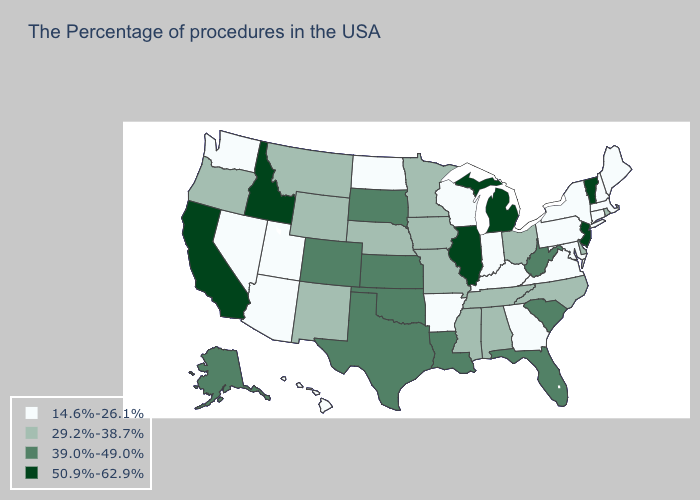Which states have the lowest value in the USA?
Keep it brief. Maine, Massachusetts, New Hampshire, Connecticut, New York, Maryland, Pennsylvania, Virginia, Georgia, Kentucky, Indiana, Wisconsin, Arkansas, North Dakota, Utah, Arizona, Nevada, Washington, Hawaii. Name the states that have a value in the range 50.9%-62.9%?
Quick response, please. Vermont, New Jersey, Michigan, Illinois, Idaho, California. Does the first symbol in the legend represent the smallest category?
Write a very short answer. Yes. Does the first symbol in the legend represent the smallest category?
Give a very brief answer. Yes. Does Idaho have the highest value in the USA?
Keep it brief. Yes. What is the value of Nebraska?
Concise answer only. 29.2%-38.7%. What is the lowest value in states that border Virginia?
Be succinct. 14.6%-26.1%. What is the highest value in states that border Nebraska?
Give a very brief answer. 39.0%-49.0%. Among the states that border New York , does Pennsylvania have the lowest value?
Be succinct. Yes. What is the highest value in states that border Louisiana?
Give a very brief answer. 39.0%-49.0%. What is the lowest value in the USA?
Keep it brief. 14.6%-26.1%. Name the states that have a value in the range 14.6%-26.1%?
Keep it brief. Maine, Massachusetts, New Hampshire, Connecticut, New York, Maryland, Pennsylvania, Virginia, Georgia, Kentucky, Indiana, Wisconsin, Arkansas, North Dakota, Utah, Arizona, Nevada, Washington, Hawaii. Name the states that have a value in the range 14.6%-26.1%?
Write a very short answer. Maine, Massachusetts, New Hampshire, Connecticut, New York, Maryland, Pennsylvania, Virginia, Georgia, Kentucky, Indiana, Wisconsin, Arkansas, North Dakota, Utah, Arizona, Nevada, Washington, Hawaii. Does Washington have the same value as Massachusetts?
Answer briefly. Yes. Among the states that border Vermont , which have the highest value?
Be succinct. Massachusetts, New Hampshire, New York. 